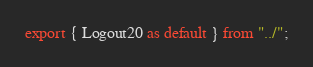Convert code to text. <code><loc_0><loc_0><loc_500><loc_500><_TypeScript_>export { Logout20 as default } from "../";
</code> 